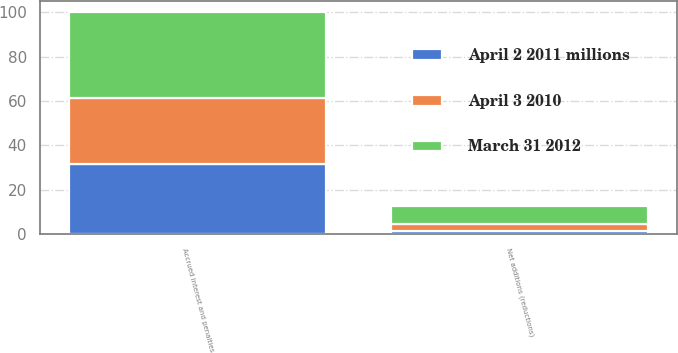Convert chart to OTSL. <chart><loc_0><loc_0><loc_500><loc_500><stacked_bar_chart><ecel><fcel>Accrued interest and penalties<fcel>Net additions (reductions)<nl><fcel>March 31 2012<fcel>39<fcel>8.3<nl><fcel>April 2 2011 millions<fcel>31.4<fcel>1.2<nl><fcel>April 3 2010<fcel>29.8<fcel>3.3<nl></chart> 